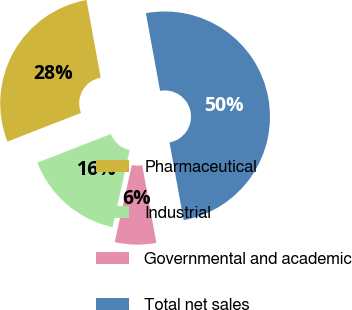<chart> <loc_0><loc_0><loc_500><loc_500><pie_chart><fcel>Pharmaceutical<fcel>Industrial<fcel>Governmental and academic<fcel>Total net sales<nl><fcel>28.03%<fcel>15.61%<fcel>6.35%<fcel>50.0%<nl></chart> 